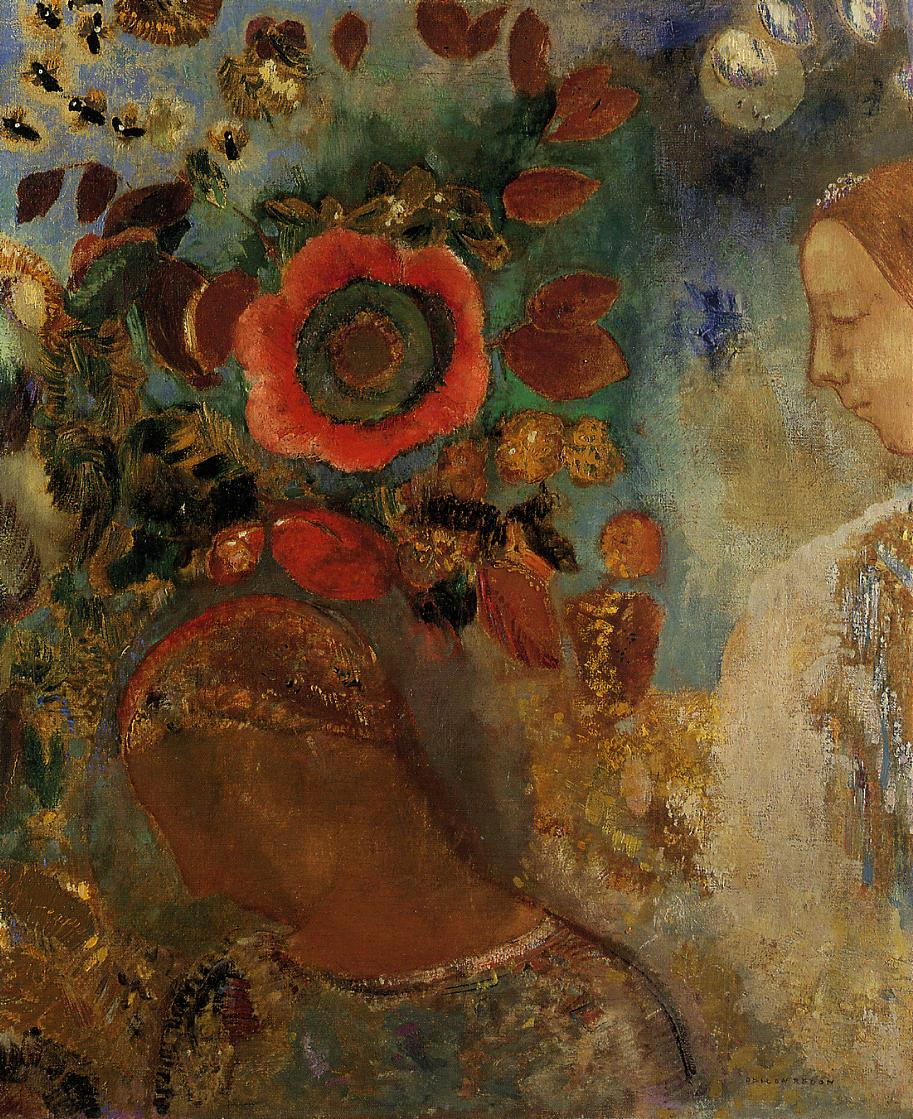Can you describe the main features of this image for me? The painting portrays a woman in profile, enveloped by a rich and dynamic floral background. Her expression exudes calmness and serenity, delicately captured to convey a peaceful, introspective mood. The woman's features and attire blend harmoniously with the lush and vibrant surroundings, highlighting the interplay between the human figure and nature. The background is adorned with bold and vibrant flowers, with a particularly striking large red bloom that captures attention due to its size and central position. The leaves and flowers surrounding her are rendered in a vibrant mix of warm and cool tones, utilizing dynamic brushstrokes typical of an impressionistic style. This creates a lively yet soothing atmosphere. Themes of nature's overwhelming beauty, human introspection, and the fusion of life and art are intricately woven into the painting through its fluid and energetic brushwork. 